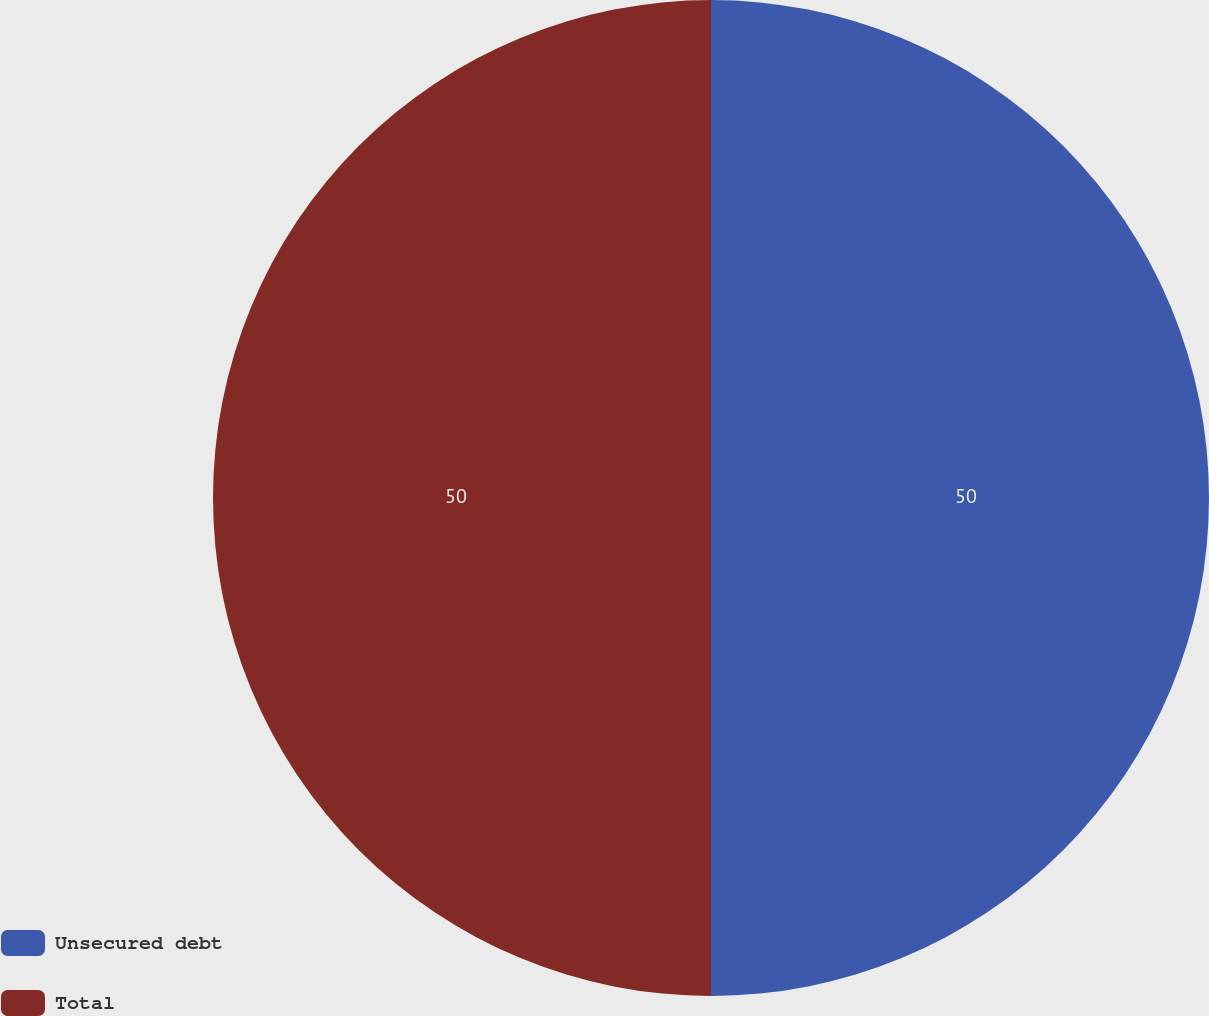<chart> <loc_0><loc_0><loc_500><loc_500><pie_chart><fcel>Unsecured debt<fcel>Total<nl><fcel>50.0%<fcel>50.0%<nl></chart> 